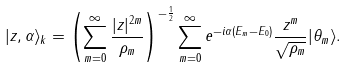<formula> <loc_0><loc_0><loc_500><loc_500>| z , \alpha \rangle _ { k } = \left ( \sum _ { m = 0 } ^ { \infty } \frac { | z | ^ { 2 m } } { \rho _ { m } } \right ) ^ { - \frac { 1 } { 2 } } \sum _ { m = 0 } ^ { \infty } e ^ { - i \alpha ( E _ { m } - E _ { 0 } ) } \frac { z ^ { m } } { \sqrt { \rho _ { m } } } | \theta _ { m } \rangle .</formula> 